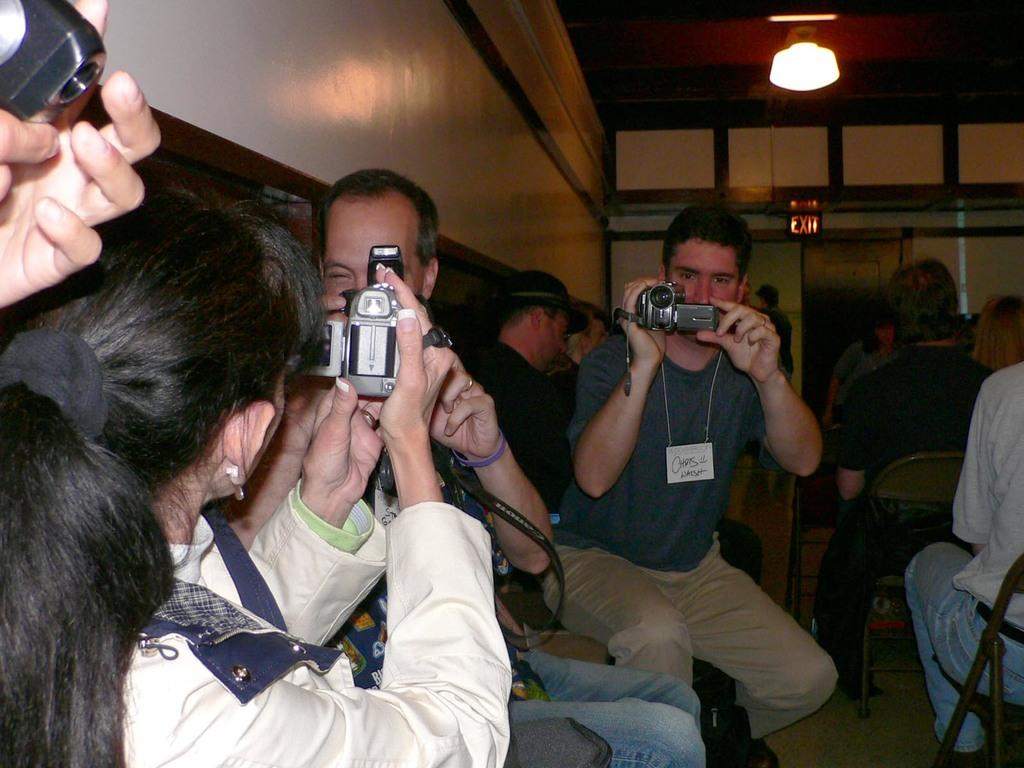How many people are in the image? There are many people in the image. What are the people doing in the image? The people are sitting. What objects do the people have in their hands? The people have video cameras in their hands. What can be seen in the background of the image? There is a wall in the image. What is the purpose of the instruction board in the image? The instruction board provides information or guidance to the people in the image. What is the source of illumination in the image? There is a light in the image. How many ducks are visible in the image? There are no ducks present in the image. What is the appropriate way to say good-bye to the people in the image? The image does not depict a situation where saying good-bye is relevant, so it is not possible to answer that question. 